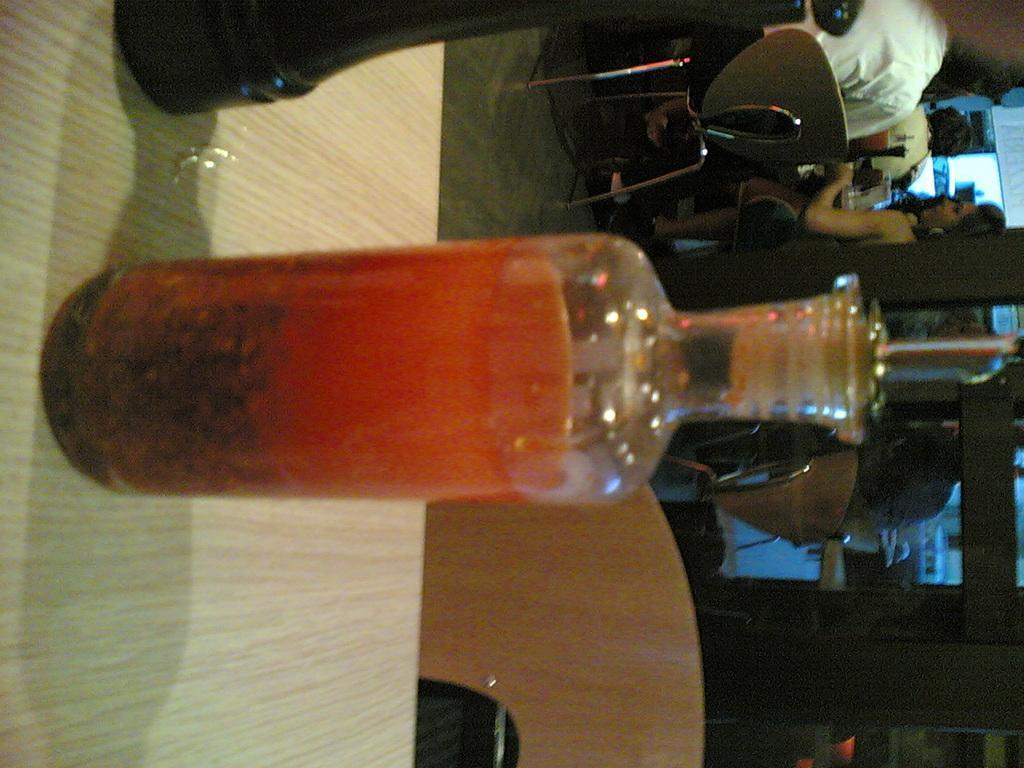How would you summarize this image in a sentence or two? In this image I can see a glass bottle on the table. To the right there are group of people sitting on the chairs. 